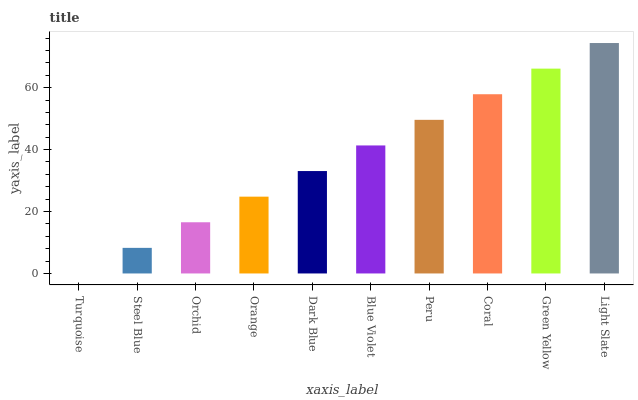Is Steel Blue the minimum?
Answer yes or no. No. Is Steel Blue the maximum?
Answer yes or no. No. Is Steel Blue greater than Turquoise?
Answer yes or no. Yes. Is Turquoise less than Steel Blue?
Answer yes or no. Yes. Is Turquoise greater than Steel Blue?
Answer yes or no. No. Is Steel Blue less than Turquoise?
Answer yes or no. No. Is Blue Violet the high median?
Answer yes or no. Yes. Is Dark Blue the low median?
Answer yes or no. Yes. Is Orange the high median?
Answer yes or no. No. Is Steel Blue the low median?
Answer yes or no. No. 